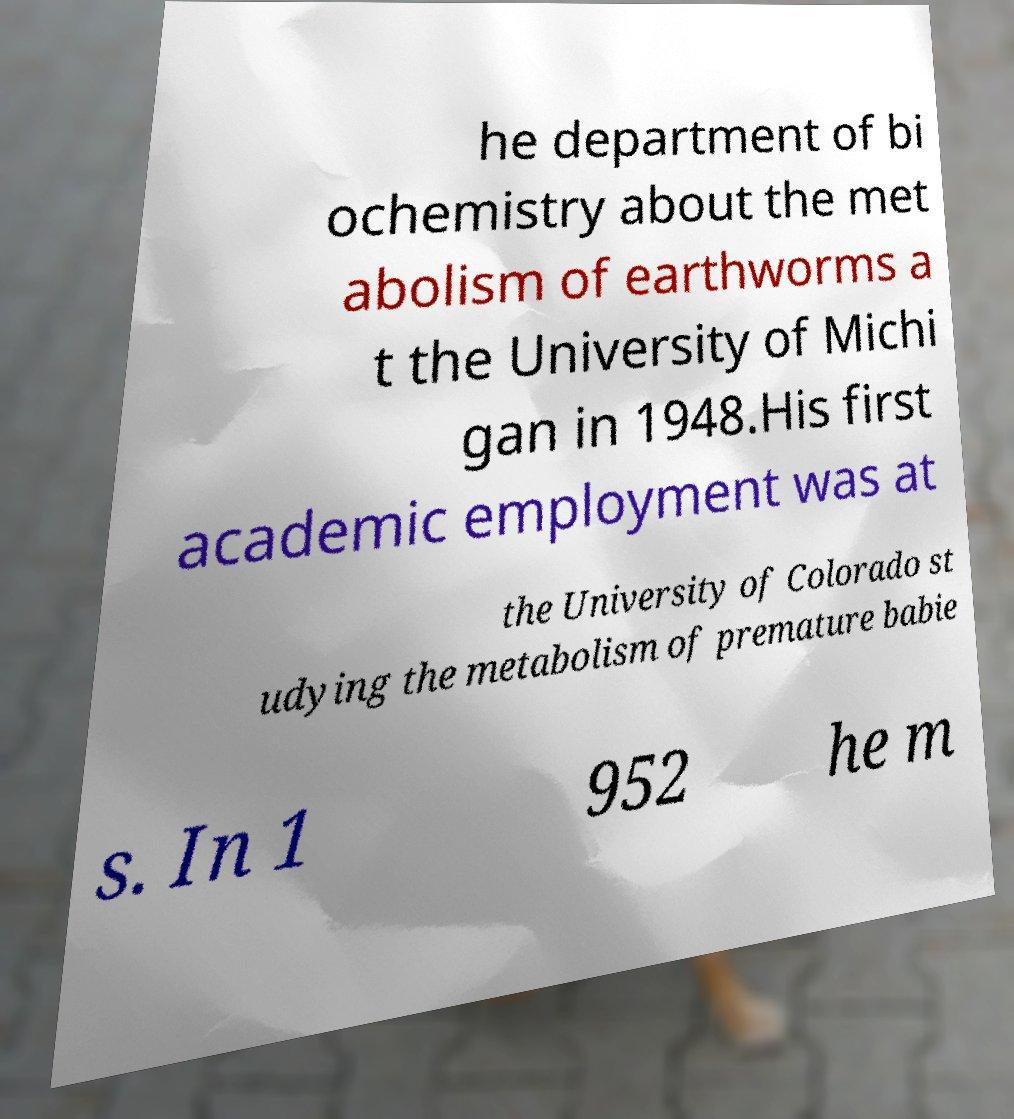I need the written content from this picture converted into text. Can you do that? he department of bi ochemistry about the met abolism of earthworms a t the University of Michi gan in 1948.His first academic employment was at the University of Colorado st udying the metabolism of premature babie s. In 1 952 he m 